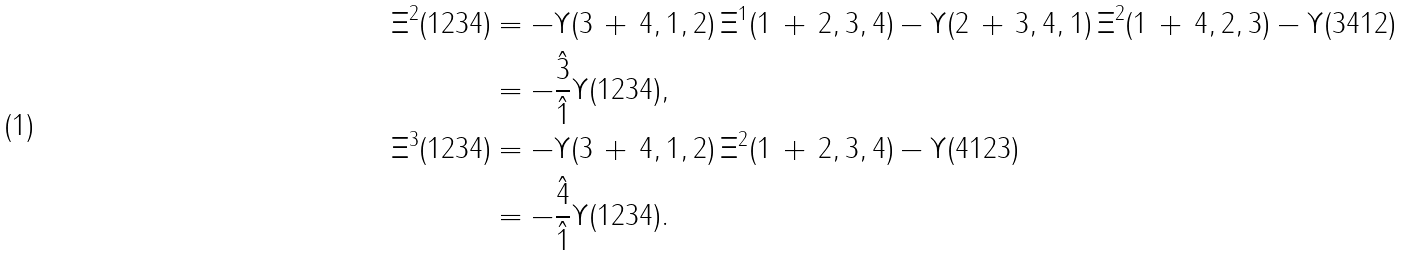Convert formula to latex. <formula><loc_0><loc_0><loc_500><loc_500>\Xi ^ { 2 } ( 1 2 3 4 ) & = - \Upsilon ( 3 \, + \, 4 , 1 , 2 ) \, \Xi ^ { 1 } ( 1 \, + \, 2 , 3 , 4 ) - \Upsilon ( 2 \, + \, 3 , 4 , 1 ) \, \Xi ^ { 2 } ( 1 \, + \, 4 , 2 , 3 ) - \Upsilon ( 3 4 1 2 ) \\ & = - \frac { \hat { 3 } } { \hat { 1 } } \Upsilon ( 1 2 3 4 ) , \\ \Xi ^ { 3 } ( 1 2 3 4 ) & = - \Upsilon ( 3 \, + \, 4 , 1 , 2 ) \, \Xi ^ { 2 } ( 1 \, + \, 2 , 3 , 4 ) - \Upsilon ( 4 1 2 3 ) \\ & = - \frac { \hat { 4 } } { \hat { 1 } } \Upsilon ( 1 2 3 4 ) .</formula> 